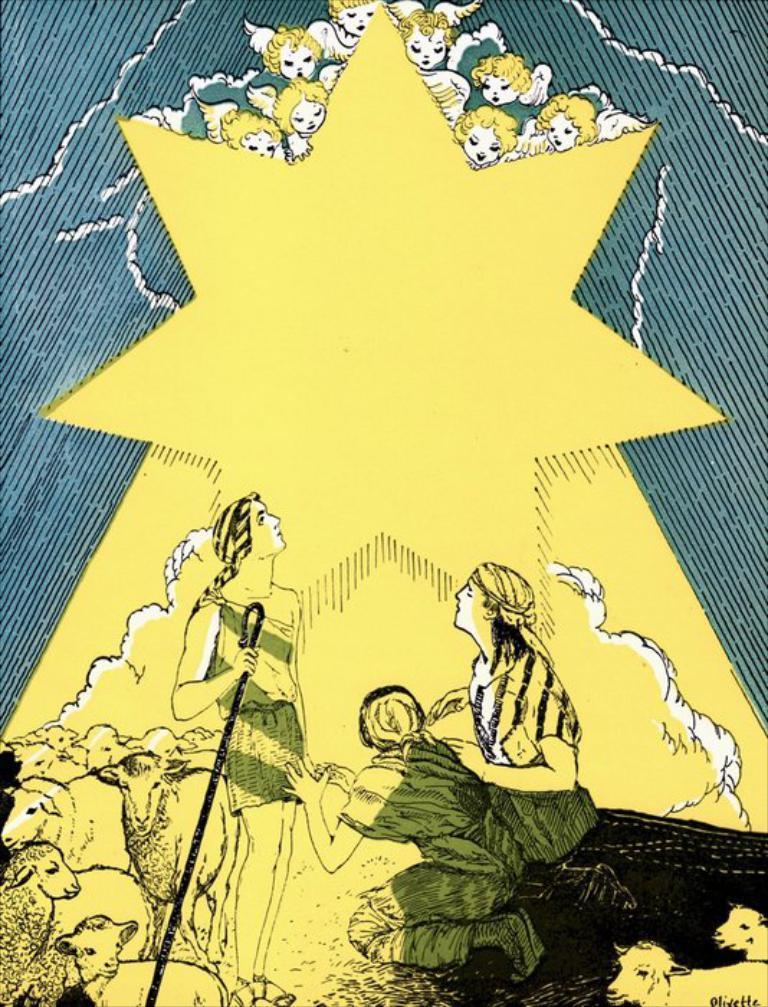Describe this image in one or two sentences. In this picture we can see poster, in this poster we can see people and animals. 